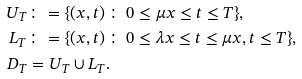<formula> <loc_0><loc_0><loc_500><loc_500>U _ { T } & \colon = \{ ( x , t ) \, \colon \, 0 \leq \mu x \leq t \leq T \} , \\ L _ { T } & \colon = \{ ( x , t ) \, \colon \, 0 \leq \lambda x \leq t \leq \mu x , t \leq T \} , \\ D _ { T } & = U _ { T } \cup L _ { T } .</formula> 